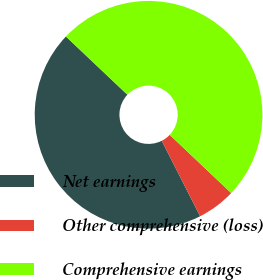Convert chart. <chart><loc_0><loc_0><loc_500><loc_500><pie_chart><fcel>Net earnings<fcel>Other comprehensive (loss)<fcel>Comprehensive earnings<nl><fcel>44.55%<fcel>5.45%<fcel>50.0%<nl></chart> 